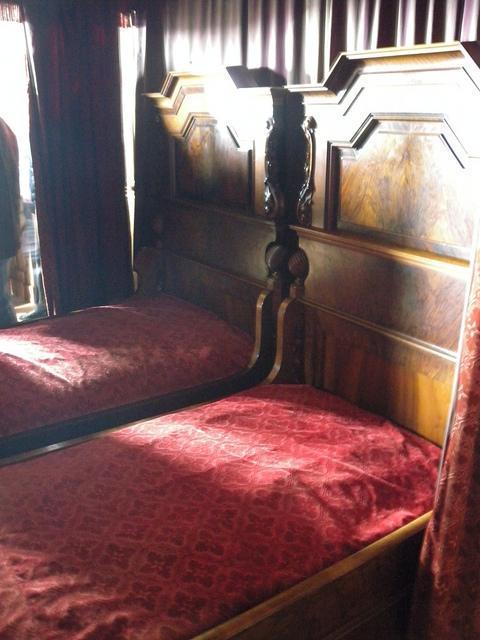What are the two areas decorated with red sheets used for?
Make your selection and explain in format: 'Answer: answer
Rationale: rationale.'
Options: Performing, serving, sleeping, gaming. Answer: sleeping.
Rationale: The areas are for sleeping. 